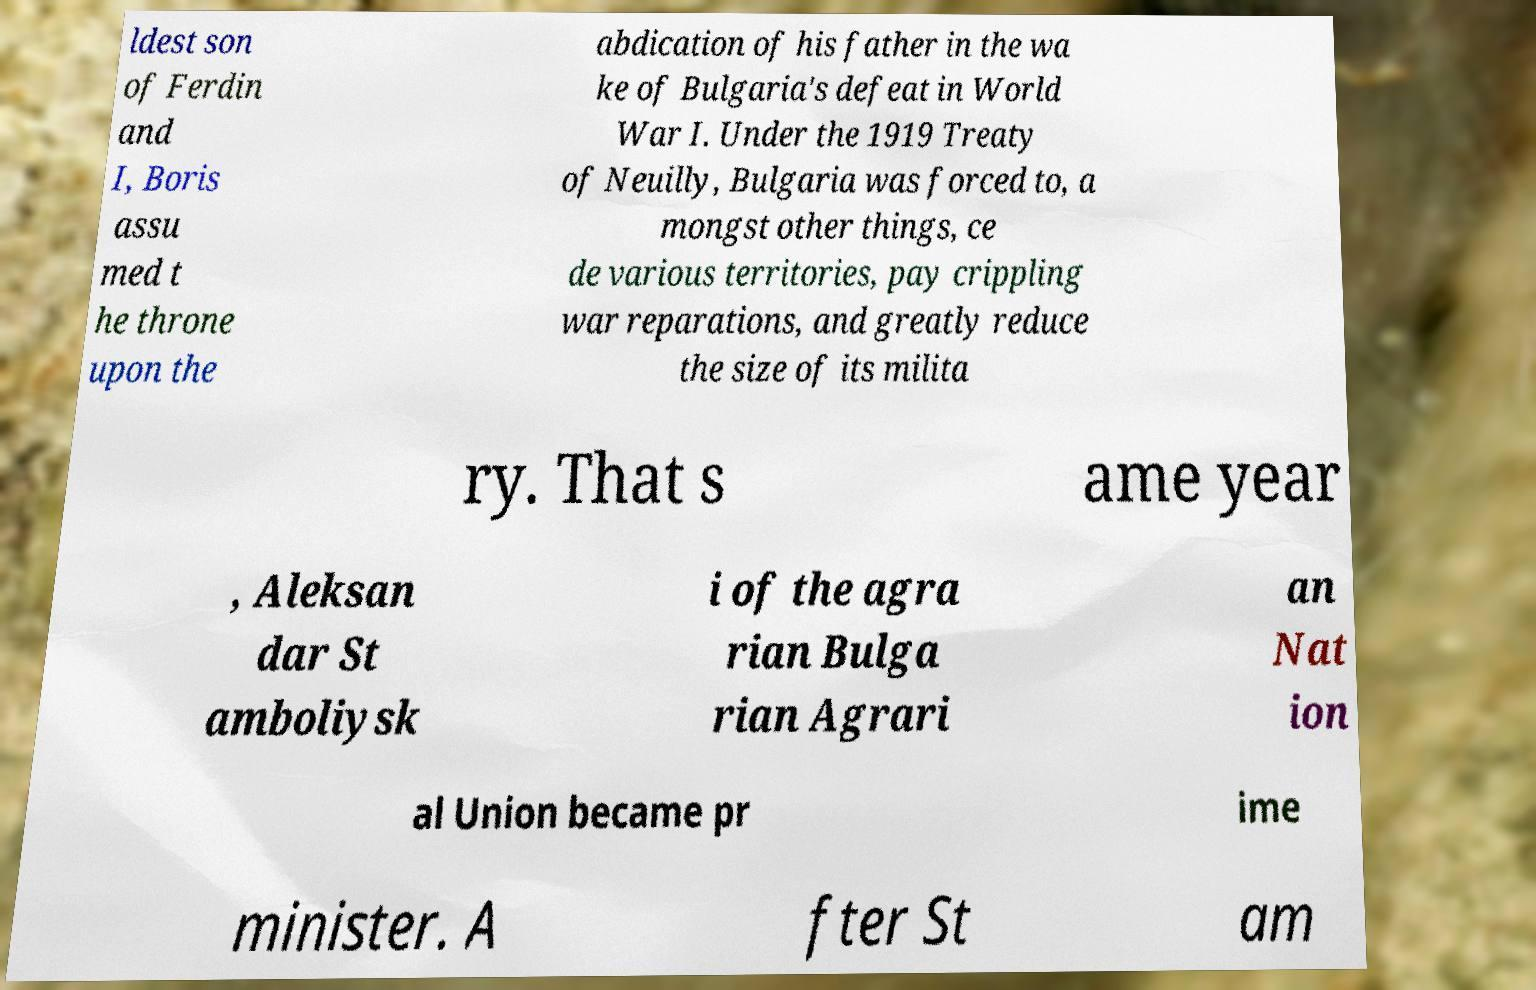Could you extract and type out the text from this image? ldest son of Ferdin and I, Boris assu med t he throne upon the abdication of his father in the wa ke of Bulgaria's defeat in World War I. Under the 1919 Treaty of Neuilly, Bulgaria was forced to, a mongst other things, ce de various territories, pay crippling war reparations, and greatly reduce the size of its milita ry. That s ame year , Aleksan dar St amboliysk i of the agra rian Bulga rian Agrari an Nat ion al Union became pr ime minister. A fter St am 